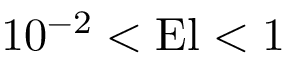<formula> <loc_0><loc_0><loc_500><loc_500>1 0 ^ { - 2 } < E l < 1</formula> 